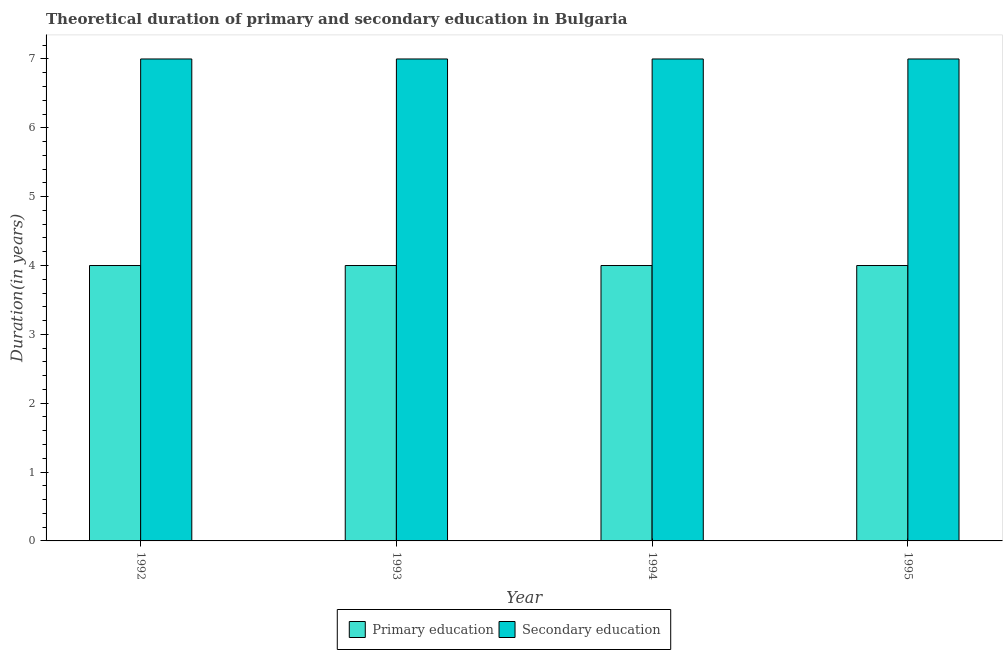How many groups of bars are there?
Ensure brevity in your answer.  4. How many bars are there on the 4th tick from the right?
Keep it short and to the point. 2. What is the label of the 3rd group of bars from the left?
Ensure brevity in your answer.  1994. In how many cases, is the number of bars for a given year not equal to the number of legend labels?
Provide a short and direct response. 0. What is the duration of secondary education in 1992?
Your answer should be compact. 7. Across all years, what is the maximum duration of secondary education?
Your response must be concise. 7. Across all years, what is the minimum duration of primary education?
Your answer should be very brief. 4. In which year was the duration of secondary education maximum?
Your response must be concise. 1992. In which year was the duration of primary education minimum?
Offer a terse response. 1992. What is the total duration of primary education in the graph?
Offer a terse response. 16. What is the difference between the duration of primary education in 1994 and that in 1995?
Your answer should be very brief. 0. What is the difference between the duration of primary education in 1992 and the duration of secondary education in 1993?
Offer a very short reply. 0. Is the duration of secondary education in 1992 less than that in 1994?
Ensure brevity in your answer.  No. What is the difference between the highest and the second highest duration of primary education?
Provide a succinct answer. 0. In how many years, is the duration of secondary education greater than the average duration of secondary education taken over all years?
Offer a very short reply. 0. What does the 2nd bar from the left in 1992 represents?
Give a very brief answer. Secondary education. What does the 1st bar from the right in 1995 represents?
Offer a terse response. Secondary education. Are all the bars in the graph horizontal?
Provide a short and direct response. No. How many years are there in the graph?
Ensure brevity in your answer.  4. What is the difference between two consecutive major ticks on the Y-axis?
Offer a terse response. 1. Are the values on the major ticks of Y-axis written in scientific E-notation?
Offer a very short reply. No. Does the graph contain any zero values?
Provide a short and direct response. No. What is the title of the graph?
Make the answer very short. Theoretical duration of primary and secondary education in Bulgaria. Does "National Visitors" appear as one of the legend labels in the graph?
Provide a short and direct response. No. What is the label or title of the X-axis?
Make the answer very short. Year. What is the label or title of the Y-axis?
Keep it short and to the point. Duration(in years). What is the Duration(in years) of Secondary education in 1993?
Keep it short and to the point. 7. What is the Duration(in years) of Primary education in 1994?
Ensure brevity in your answer.  4. What is the Duration(in years) of Secondary education in 1994?
Give a very brief answer. 7. What is the Duration(in years) in Secondary education in 1995?
Your response must be concise. 7. Across all years, what is the minimum Duration(in years) of Secondary education?
Your answer should be very brief. 7. What is the total Duration(in years) in Primary education in the graph?
Offer a terse response. 16. What is the difference between the Duration(in years) of Secondary education in 1992 and that in 1994?
Provide a succinct answer. 0. What is the difference between the Duration(in years) in Primary education in 1992 and that in 1995?
Your answer should be very brief. 0. What is the difference between the Duration(in years) in Primary education in 1993 and that in 1994?
Make the answer very short. 0. What is the difference between the Duration(in years) of Secondary education in 1993 and that in 1994?
Provide a short and direct response. 0. What is the difference between the Duration(in years) of Secondary education in 1994 and that in 1995?
Your answer should be very brief. 0. What is the difference between the Duration(in years) of Primary education in 1992 and the Duration(in years) of Secondary education in 1995?
Your answer should be very brief. -3. What is the difference between the Duration(in years) in Primary education in 1993 and the Duration(in years) in Secondary education in 1995?
Provide a short and direct response. -3. What is the average Duration(in years) of Primary education per year?
Your answer should be very brief. 4. What is the average Duration(in years) in Secondary education per year?
Your response must be concise. 7. In the year 1992, what is the difference between the Duration(in years) of Primary education and Duration(in years) of Secondary education?
Provide a succinct answer. -3. In the year 1994, what is the difference between the Duration(in years) in Primary education and Duration(in years) in Secondary education?
Offer a very short reply. -3. In the year 1995, what is the difference between the Duration(in years) of Primary education and Duration(in years) of Secondary education?
Provide a succinct answer. -3. What is the ratio of the Duration(in years) in Primary education in 1992 to that in 1993?
Provide a succinct answer. 1. What is the ratio of the Duration(in years) of Primary education in 1992 to that in 1994?
Ensure brevity in your answer.  1. What is the ratio of the Duration(in years) in Secondary education in 1992 to that in 1995?
Offer a terse response. 1. What is the ratio of the Duration(in years) in Primary education in 1993 to that in 1994?
Your response must be concise. 1. What is the ratio of the Duration(in years) of Secondary education in 1993 to that in 1994?
Give a very brief answer. 1. What is the ratio of the Duration(in years) of Primary education in 1993 to that in 1995?
Ensure brevity in your answer.  1. What is the ratio of the Duration(in years) in Secondary education in 1993 to that in 1995?
Provide a succinct answer. 1. What is the ratio of the Duration(in years) of Primary education in 1994 to that in 1995?
Offer a terse response. 1. What is the difference between the highest and the second highest Duration(in years) in Primary education?
Offer a very short reply. 0. What is the difference between the highest and the second highest Duration(in years) of Secondary education?
Keep it short and to the point. 0. What is the difference between the highest and the lowest Duration(in years) in Primary education?
Your answer should be compact. 0. What is the difference between the highest and the lowest Duration(in years) in Secondary education?
Offer a terse response. 0. 